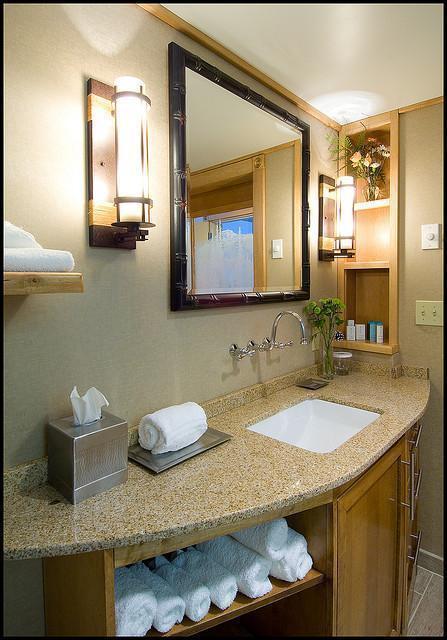How many mirrors are in the picture?
Give a very brief answer. 1. How many horses are there?
Give a very brief answer. 0. 